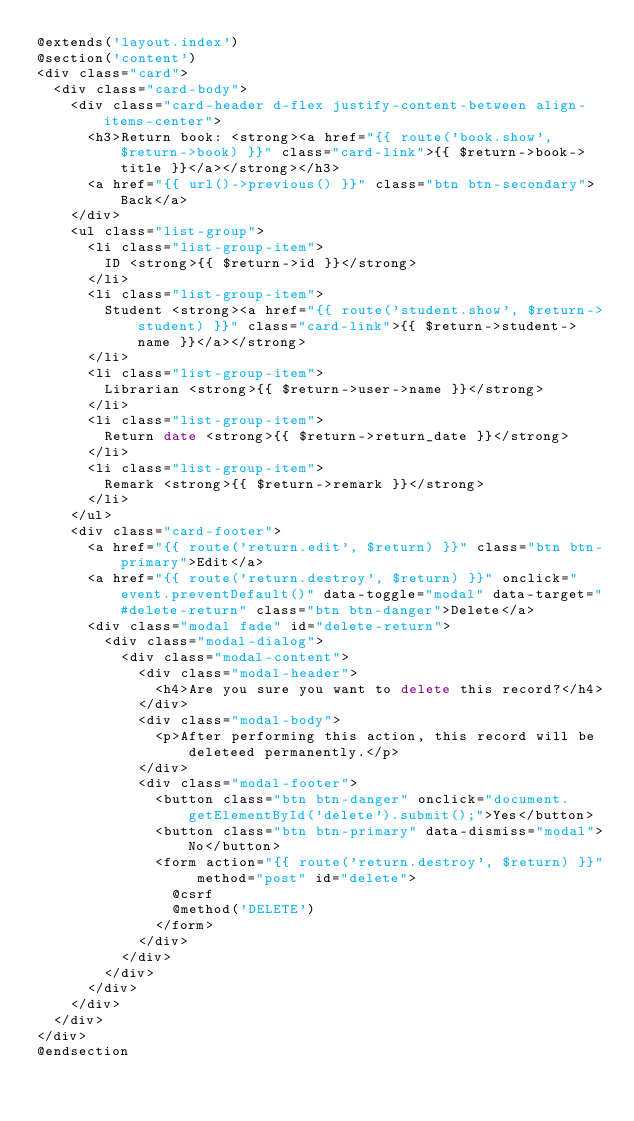<code> <loc_0><loc_0><loc_500><loc_500><_PHP_>@extends('layout.index')
@section('content')
<div class="card">
  <div class="card-body">
    <div class="card-header d-flex justify-content-between align-items-center">
      <h3>Return book: <strong><a href="{{ route('book.show', $return->book) }}" class="card-link">{{ $return->book->title }}</a></strong></h3>
      <a href="{{ url()->previous() }}" class="btn btn-secondary">Back</a>
    </div>
    <ul class="list-group">
      <li class="list-group-item">
        ID <strong>{{ $return->id }}</strong>
      </li>
      <li class="list-group-item">
        Student <strong><a href="{{ route('student.show', $return->student) }}" class="card-link">{{ $return->student->name }}</a></strong>
      </li>
      <li class="list-group-item">
        Librarian <strong>{{ $return->user->name }}</strong>
      </li>
      <li class="list-group-item">
        Return date <strong>{{ $return->return_date }}</strong>
      </li>
      <li class="list-group-item">
        Remark <strong>{{ $return->remark }}</strong>
      </li>
    </ul>
    <div class="card-footer">
      <a href="{{ route('return.edit', $return) }}" class="btn btn-primary">Edit</a>
      <a href="{{ route('return.destroy', $return) }}" onclick="event.preventDefault()" data-toggle="modal" data-target="#delete-return" class="btn btn-danger">Delete</a>
      <div class="modal fade" id="delete-return">
        <div class="modal-dialog">
          <div class="modal-content">
            <div class="modal-header">
              <h4>Are you sure you want to delete this record?</h4>
            </div>
            <div class="modal-body">
              <p>After performing this action, this record will be deleteed permanently.</p>
            </div>
            <div class="modal-footer">
              <button class="btn btn-danger" onclick="document.getElementById('delete').submit();">Yes</button>
              <button class="btn btn-primary" data-dismiss="modal">No</button>
              <form action="{{ route('return.destroy', $return) }}" method="post" id="delete">
                @csrf
                @method('DELETE')
              </form>
            </div>
          </div>
        </div>
      </div>
    </div>
  </div>
</div>
@endsection</code> 